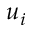Convert formula to latex. <formula><loc_0><loc_0><loc_500><loc_500>u _ { i }</formula> 